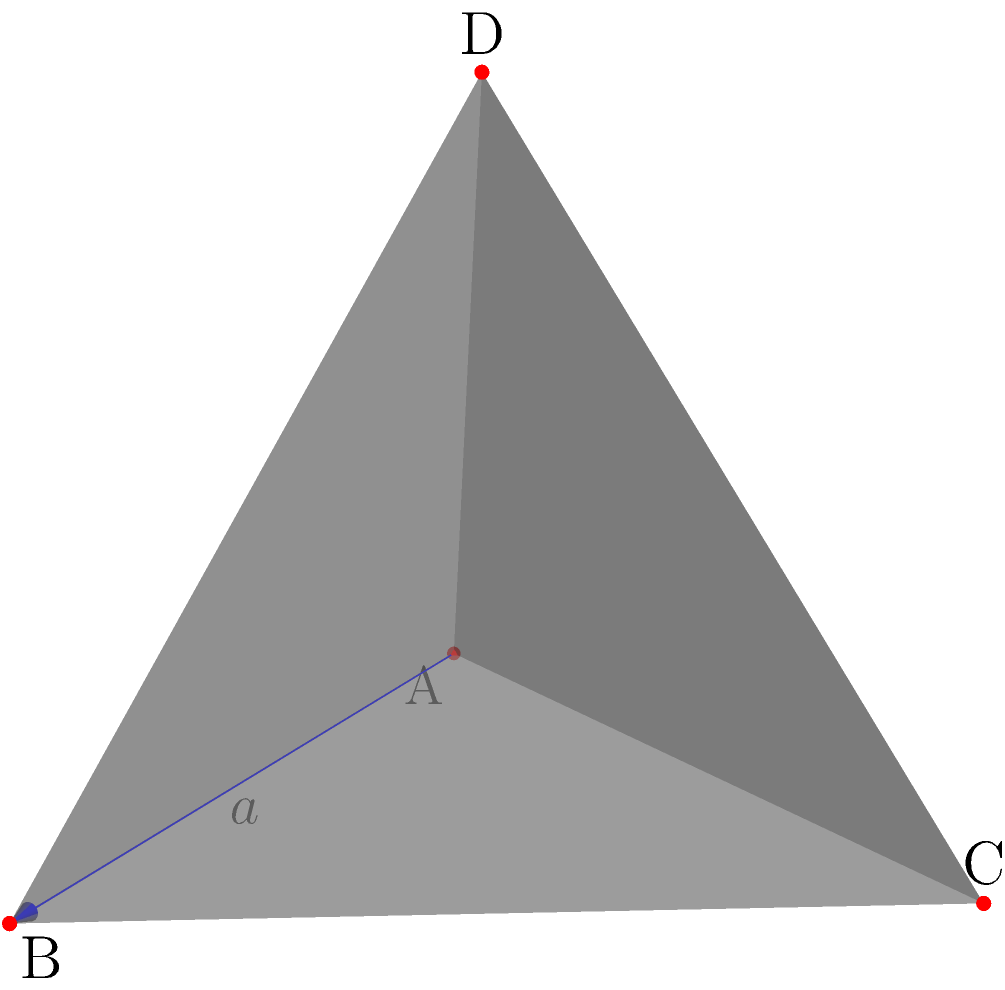In your work supporting trauma victims, you often use metaphors to explain complex emotional processes. Consider a tetrahedron as a representation of the healing journey, where each edge symbolizes a different aspect of recovery. If the length of each edge (a) is 6 units, representing the time it takes to fully process a traumatic event, what is the volume of this healing space? Let's approach this step-by-step:

1) The volume of a regular tetrahedron is given by the formula:

   $$V = \frac{\sqrt{2}}{12}a^3$$

   where $a$ is the length of an edge.

2) We are given that $a = 6$ units.

3) Let's substitute this into our formula:

   $$V = \frac{\sqrt{2}}{12}(6)^3$$

4) Simplify the cube:
   
   $$V = \frac{\sqrt{2}}{12}(216)$$

5) Multiply:

   $$V = 18\sqrt{2}$$

6) This can be simplified to:

   $$V = 9\sqrt{8}$$

7) Simplify the square root:

   $$V = 9 \cdot 2\sqrt{2} = 18\sqrt{2}$$

Thus, the volume of the tetrahedron, representing the space of healing, is $18\sqrt{2}$ cubic units.
Answer: $18\sqrt{2}$ cubic units 